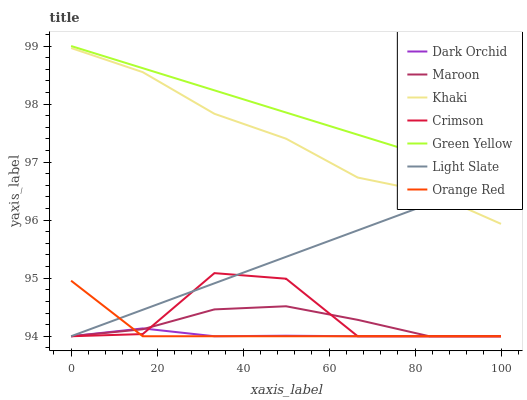Does Dark Orchid have the minimum area under the curve?
Answer yes or no. Yes. Does Green Yellow have the maximum area under the curve?
Answer yes or no. Yes. Does Light Slate have the minimum area under the curve?
Answer yes or no. No. Does Light Slate have the maximum area under the curve?
Answer yes or no. No. Is Light Slate the smoothest?
Answer yes or no. Yes. Is Crimson the roughest?
Answer yes or no. Yes. Is Maroon the smoothest?
Answer yes or no. No. Is Maroon the roughest?
Answer yes or no. No. Does Light Slate have the lowest value?
Answer yes or no. Yes. Does Green Yellow have the lowest value?
Answer yes or no. No. Does Green Yellow have the highest value?
Answer yes or no. Yes. Does Light Slate have the highest value?
Answer yes or no. No. Is Orange Red less than Green Yellow?
Answer yes or no. Yes. Is Khaki greater than Dark Orchid?
Answer yes or no. Yes. Does Orange Red intersect Light Slate?
Answer yes or no. Yes. Is Orange Red less than Light Slate?
Answer yes or no. No. Is Orange Red greater than Light Slate?
Answer yes or no. No. Does Orange Red intersect Green Yellow?
Answer yes or no. No. 